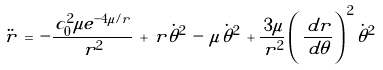<formula> <loc_0><loc_0><loc_500><loc_500>\ddot { r } \, = \, - \frac { \, c _ { 0 } ^ { 2 } \mu e ^ { - 4 \mu / r } } { \, r ^ { 2 } } \, + \, r \dot { \theta } ^ { 2 } \, - \, \mu \dot { \theta } ^ { 2 } \, + \frac { \, 3 \mu } { \, r ^ { 2 } } \left ( \, \frac { \, d r } { \, d \theta } \right ) ^ { \, 2 } \dot { \theta } ^ { 2 }</formula> 